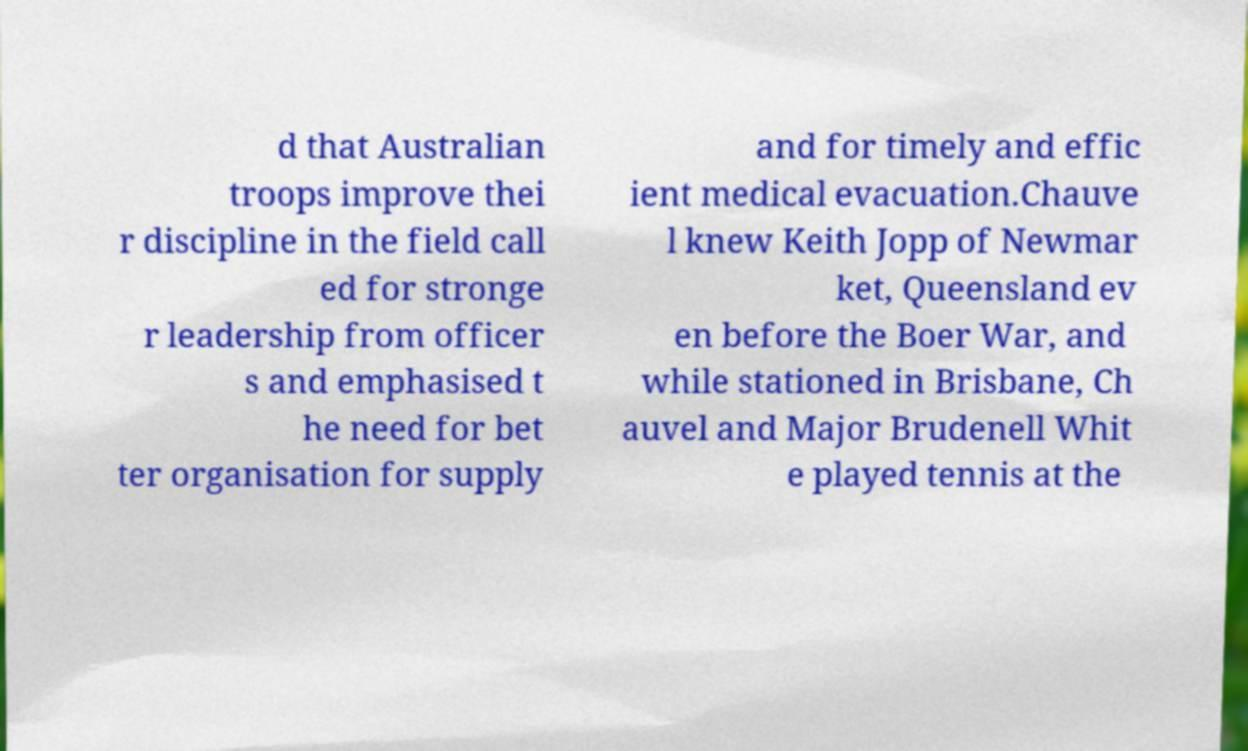For documentation purposes, I need the text within this image transcribed. Could you provide that? d that Australian troops improve thei r discipline in the field call ed for stronge r leadership from officer s and emphasised t he need for bet ter organisation for supply and for timely and effic ient medical evacuation.Chauve l knew Keith Jopp of Newmar ket, Queensland ev en before the Boer War, and while stationed in Brisbane, Ch auvel and Major Brudenell Whit e played tennis at the 